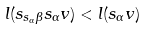<formula> <loc_0><loc_0><loc_500><loc_500>l ( s _ { s _ { \alpha } \beta } s _ { \alpha } v ) < l ( s _ { \alpha } v )</formula> 